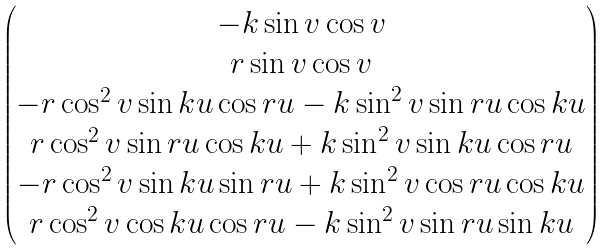Convert formula to latex. <formula><loc_0><loc_0><loc_500><loc_500>\begin{pmatrix} - k \sin v \cos v \\ r \sin v \cos v \\ - r \cos ^ { 2 } v \sin k u \cos r u - k \sin ^ { 2 } v \sin r u \cos k u \\ r \cos ^ { 2 } v \sin r u \cos k u + k \sin ^ { 2 } v \sin k u \cos r u \\ - r \cos ^ { 2 } v \sin k u \sin r u + k \sin ^ { 2 } v \cos r u \cos k u \\ r \cos ^ { 2 } v \cos k u \cos r u - k \sin ^ { 2 } v \sin r u \sin k u \\ \end{pmatrix}</formula> 